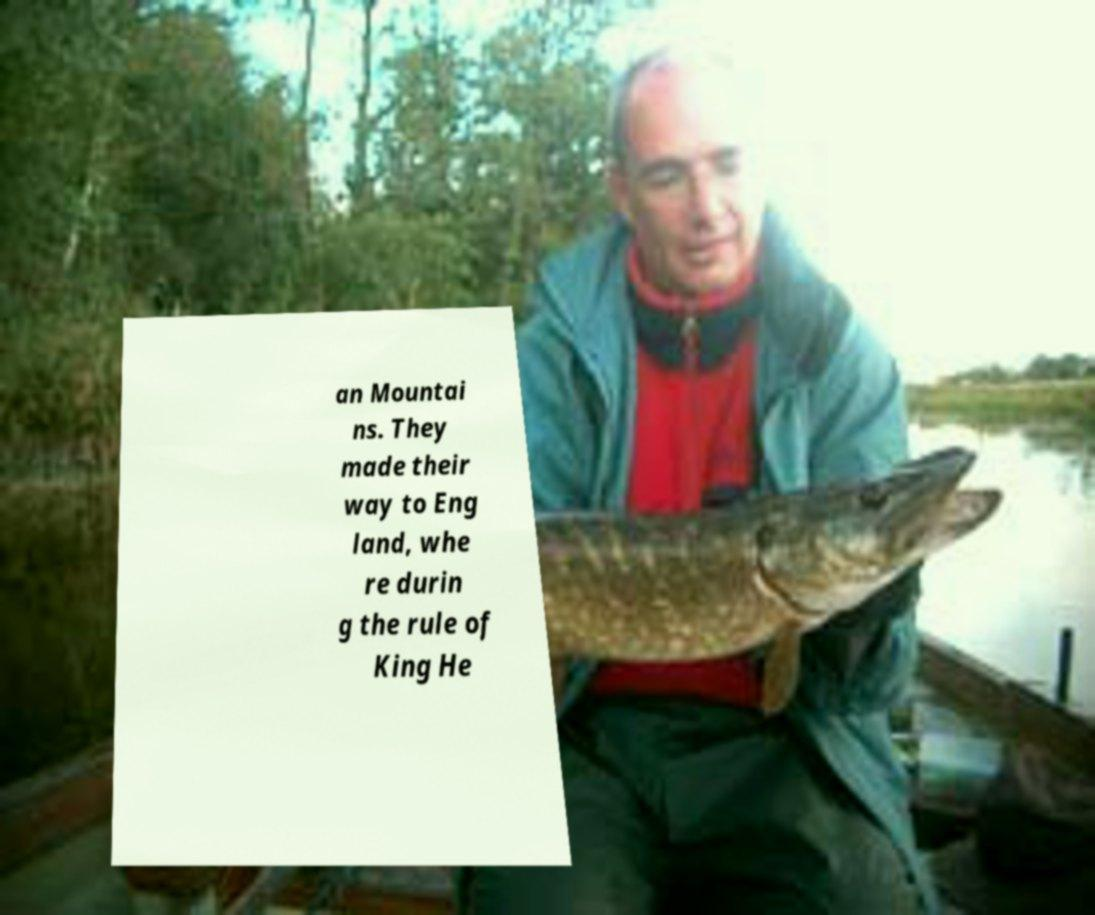Could you extract and type out the text from this image? an Mountai ns. They made their way to Eng land, whe re durin g the rule of King He 